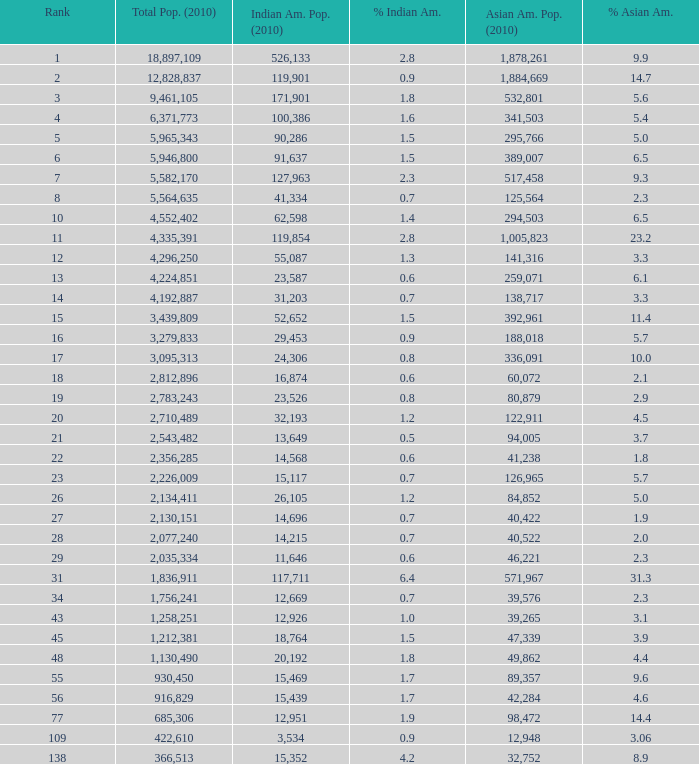What's the total population when the Asian American population is less than 60,072, the Indian American population is more than 14,696 and is 4.2% Indian American? 366513.0. 